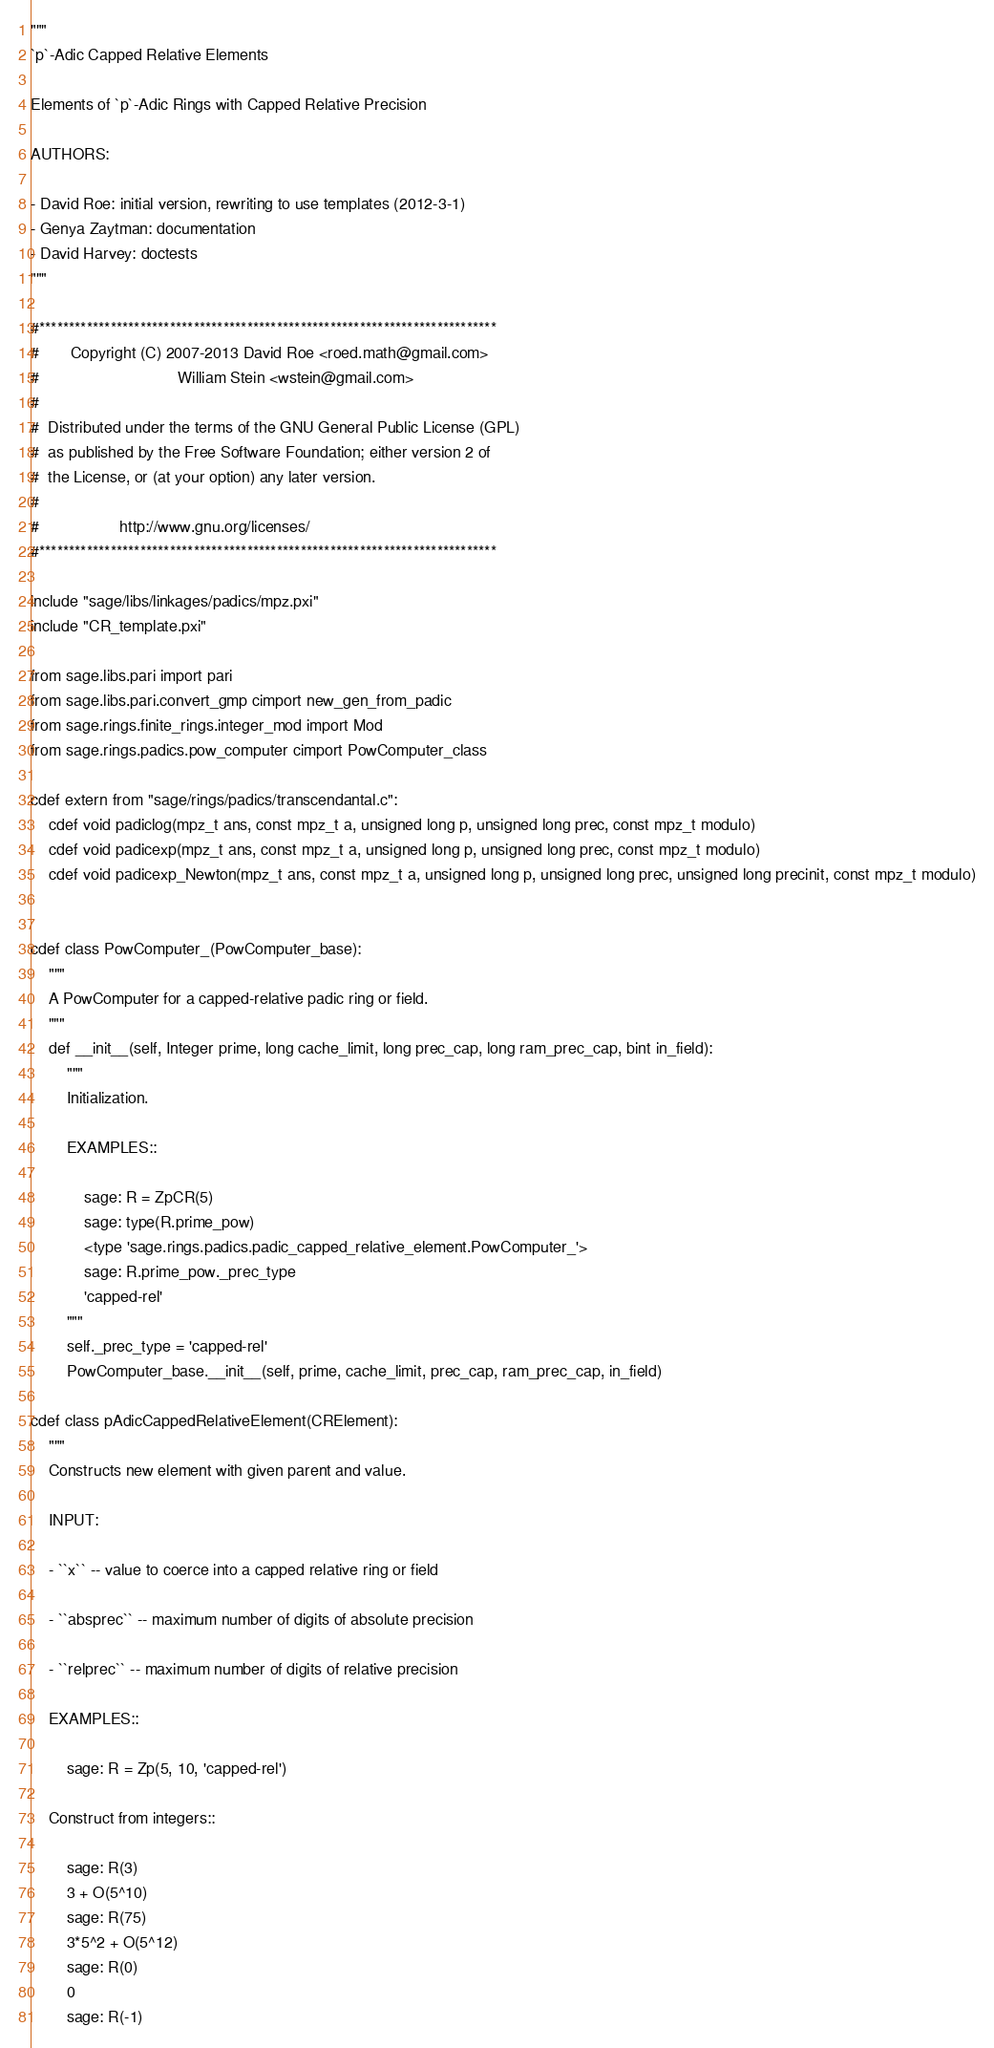Convert code to text. <code><loc_0><loc_0><loc_500><loc_500><_Cython_>"""
`p`-Adic Capped Relative Elements

Elements of `p`-Adic Rings with Capped Relative Precision

AUTHORS:

- David Roe: initial version, rewriting to use templates (2012-3-1)
- Genya Zaytman: documentation
- David Harvey: doctests
"""

#*****************************************************************************
#       Copyright (C) 2007-2013 David Roe <roed.math@gmail.com>
#                               William Stein <wstein@gmail.com>
#
#  Distributed under the terms of the GNU General Public License (GPL)
#  as published by the Free Software Foundation; either version 2 of
#  the License, or (at your option) any later version.
#
#                  http://www.gnu.org/licenses/
#*****************************************************************************

include "sage/libs/linkages/padics/mpz.pxi"
include "CR_template.pxi"

from sage.libs.pari import pari
from sage.libs.pari.convert_gmp cimport new_gen_from_padic
from sage.rings.finite_rings.integer_mod import Mod
from sage.rings.padics.pow_computer cimport PowComputer_class

cdef extern from "sage/rings/padics/transcendantal.c":
    cdef void padiclog(mpz_t ans, const mpz_t a, unsigned long p, unsigned long prec, const mpz_t modulo)
    cdef void padicexp(mpz_t ans, const mpz_t a, unsigned long p, unsigned long prec, const mpz_t modulo)  
    cdef void padicexp_Newton(mpz_t ans, const mpz_t a, unsigned long p, unsigned long prec, unsigned long precinit, const mpz_t modulo)


cdef class PowComputer_(PowComputer_base):
    """
    A PowComputer for a capped-relative padic ring or field.
    """
    def __init__(self, Integer prime, long cache_limit, long prec_cap, long ram_prec_cap, bint in_field):
        """
        Initialization.

        EXAMPLES::

            sage: R = ZpCR(5)
            sage: type(R.prime_pow)
            <type 'sage.rings.padics.padic_capped_relative_element.PowComputer_'>
            sage: R.prime_pow._prec_type
            'capped-rel'
        """
        self._prec_type = 'capped-rel'
        PowComputer_base.__init__(self, prime, cache_limit, prec_cap, ram_prec_cap, in_field)

cdef class pAdicCappedRelativeElement(CRElement):
    """
    Constructs new element with given parent and value.

    INPUT:

    - ``x`` -- value to coerce into a capped relative ring or field

    - ``absprec`` -- maximum number of digits of absolute precision

    - ``relprec`` -- maximum number of digits of relative precision

    EXAMPLES::

        sage: R = Zp(5, 10, 'capped-rel')

    Construct from integers::

        sage: R(3)
        3 + O(5^10)
        sage: R(75)
        3*5^2 + O(5^12)
        sage: R(0)
        0
        sage: R(-1)</code> 